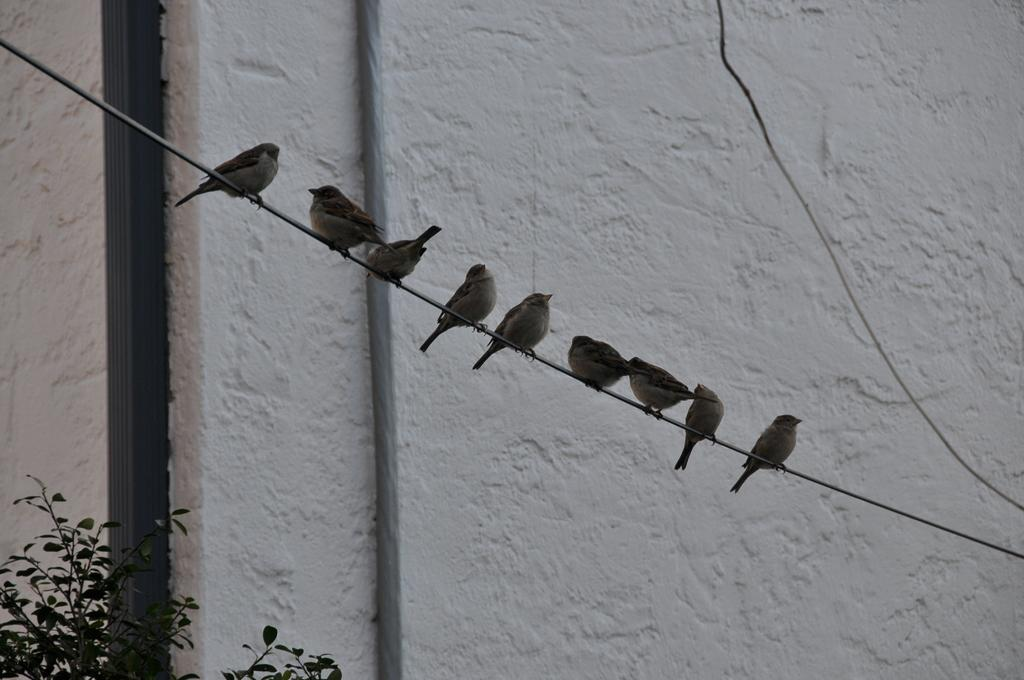What is on the wire in the image? There are birds on the wire in the image. What colors are the birds? The birds are in brown and cream color. What can be seen in the background of the image? There are plants in the background of the image. What color are the plants? The plants are green in color. What color is the wall in the background? The wall in the background is white in color. What type of beef is being prepared in the image? There is no beef or any indication of food preparation in the image; it features birds on a wire, plants, and a white wall in the background. 